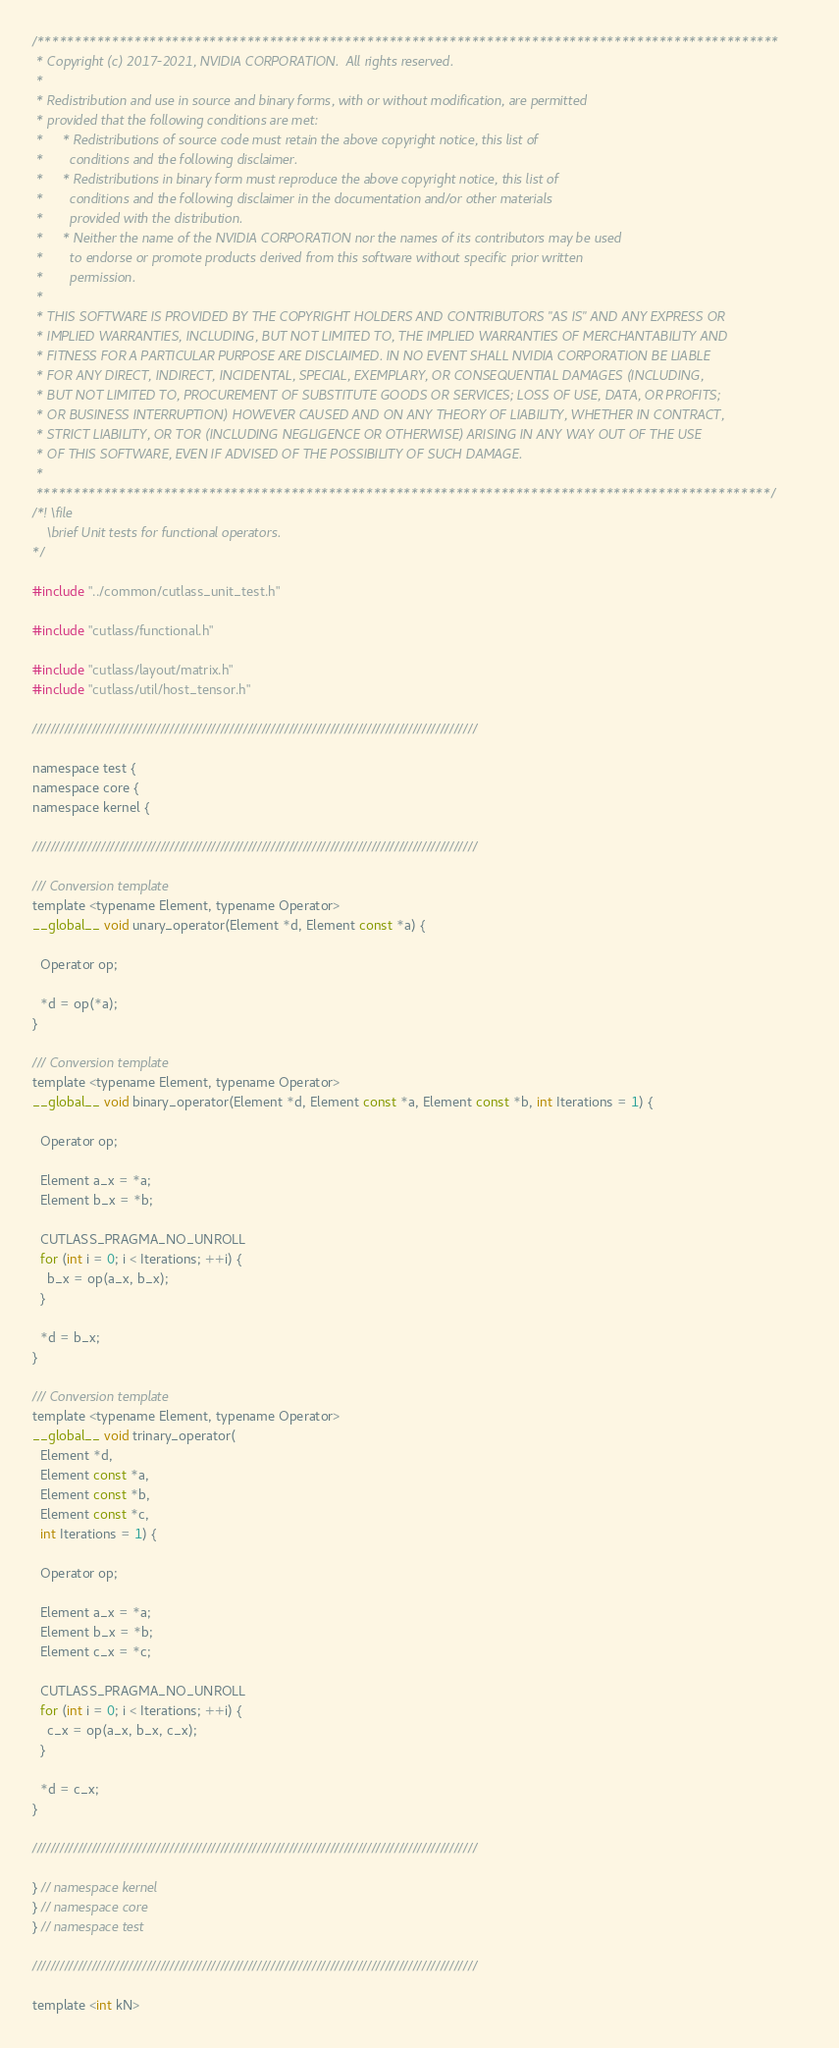<code> <loc_0><loc_0><loc_500><loc_500><_Cuda_>/***************************************************************************************************
 * Copyright (c) 2017-2021, NVIDIA CORPORATION.  All rights reserved.
 *
 * Redistribution and use in source and binary forms, with or without modification, are permitted
 * provided that the following conditions are met:
 *     * Redistributions of source code must retain the above copyright notice, this list of
 *       conditions and the following disclaimer.
 *     * Redistributions in binary form must reproduce the above copyright notice, this list of
 *       conditions and the following disclaimer in the documentation and/or other materials
 *       provided with the distribution.
 *     * Neither the name of the NVIDIA CORPORATION nor the names of its contributors may be used
 *       to endorse or promote products derived from this software without specific prior written
 *       permission.
 *
 * THIS SOFTWARE IS PROVIDED BY THE COPYRIGHT HOLDERS AND CONTRIBUTORS "AS IS" AND ANY EXPRESS OR
 * IMPLIED WARRANTIES, INCLUDING, BUT NOT LIMITED TO, THE IMPLIED WARRANTIES OF MERCHANTABILITY AND
 * FITNESS FOR A PARTICULAR PURPOSE ARE DISCLAIMED. IN NO EVENT SHALL NVIDIA CORPORATION BE LIABLE
 * FOR ANY DIRECT, INDIRECT, INCIDENTAL, SPECIAL, EXEMPLARY, OR CONSEQUENTIAL DAMAGES (INCLUDING,
 * BUT NOT LIMITED TO, PROCUREMENT OF SUBSTITUTE GOODS OR SERVICES; LOSS OF USE, DATA, OR PROFITS;
 * OR BUSINESS INTERRUPTION) HOWEVER CAUSED AND ON ANY THEORY OF LIABILITY, WHETHER IN CONTRACT,
 * STRICT LIABILITY, OR TOR (INCLUDING NEGLIGENCE OR OTHERWISE) ARISING IN ANY WAY OUT OF THE USE
 * OF THIS SOFTWARE, EVEN IF ADVISED OF THE POSSIBILITY OF SUCH DAMAGE.
 *
 **************************************************************************************************/
/*! \file
    \brief Unit tests for functional operators.
*/

#include "../common/cutlass_unit_test.h"

#include "cutlass/functional.h"

#include "cutlass/layout/matrix.h"
#include "cutlass/util/host_tensor.h"

/////////////////////////////////////////////////////////////////////////////////////////////////

namespace test {
namespace core {
namespace kernel {

/////////////////////////////////////////////////////////////////////////////////////////////////

/// Conversion template
template <typename Element, typename Operator>
__global__ void unary_operator(Element *d, Element const *a) {

  Operator op;

  *d = op(*a);
}

/// Conversion template
template <typename Element, typename Operator>
__global__ void binary_operator(Element *d, Element const *a, Element const *b, int Iterations = 1) {

  Operator op;

  Element a_x = *a;
  Element b_x = *b;

  CUTLASS_PRAGMA_NO_UNROLL
  for (int i = 0; i < Iterations; ++i) {
    b_x = op(a_x, b_x);
  }
  
  *d = b_x;
}

/// Conversion template
template <typename Element, typename Operator>
__global__ void trinary_operator(
  Element *d, 
  Element const *a, 
  Element const *b, 
  Element const *c, 
  int Iterations = 1) {

  Operator op;

  Element a_x = *a;
  Element b_x = *b;
  Element c_x = *c;

  CUTLASS_PRAGMA_NO_UNROLL
  for (int i = 0; i < Iterations; ++i) {
    c_x = op(a_x, b_x, c_x);
  }
  
  *d = c_x;
}

/////////////////////////////////////////////////////////////////////////////////////////////////

} // namespace kernel
} // namespace core
} // namespace test

/////////////////////////////////////////////////////////////////////////////////////////////////

template <int kN></code> 